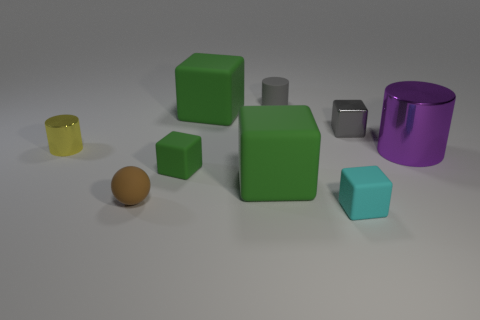Subtract all brown spheres. How many green cubes are left? 3 Subtract all cyan rubber blocks. How many blocks are left? 4 Subtract all gray cubes. How many cubes are left? 4 Subtract all red blocks. Subtract all cyan cylinders. How many blocks are left? 5 Subtract all spheres. How many objects are left? 8 Add 7 balls. How many balls are left? 8 Add 5 red metal cylinders. How many red metal cylinders exist? 5 Subtract 1 gray cylinders. How many objects are left? 8 Subtract all cyan objects. Subtract all tiny rubber spheres. How many objects are left? 7 